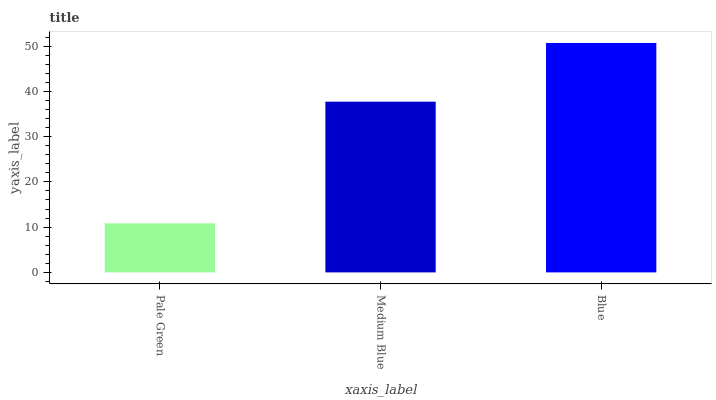Is Pale Green the minimum?
Answer yes or no. Yes. Is Blue the maximum?
Answer yes or no. Yes. Is Medium Blue the minimum?
Answer yes or no. No. Is Medium Blue the maximum?
Answer yes or no. No. Is Medium Blue greater than Pale Green?
Answer yes or no. Yes. Is Pale Green less than Medium Blue?
Answer yes or no. Yes. Is Pale Green greater than Medium Blue?
Answer yes or no. No. Is Medium Blue less than Pale Green?
Answer yes or no. No. Is Medium Blue the high median?
Answer yes or no. Yes. Is Medium Blue the low median?
Answer yes or no. Yes. Is Blue the high median?
Answer yes or no. No. Is Pale Green the low median?
Answer yes or no. No. 